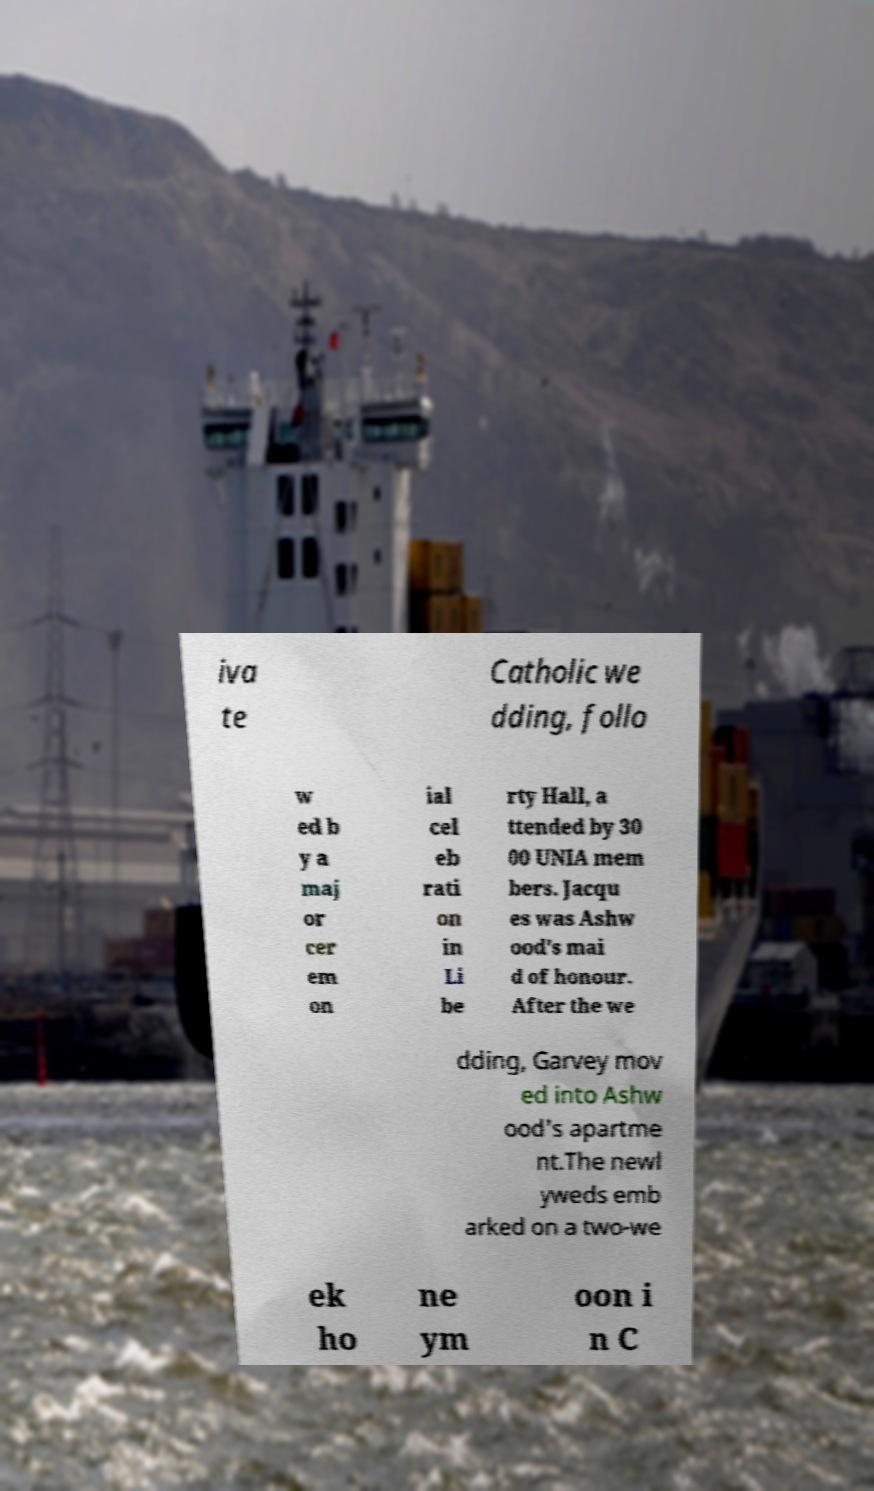Could you extract and type out the text from this image? iva te Catholic we dding, follo w ed b y a maj or cer em on ial cel eb rati on in Li be rty Hall, a ttended by 30 00 UNIA mem bers. Jacqu es was Ashw ood's mai d of honour. After the we dding, Garvey mov ed into Ashw ood's apartme nt.The newl yweds emb arked on a two-we ek ho ne ym oon i n C 